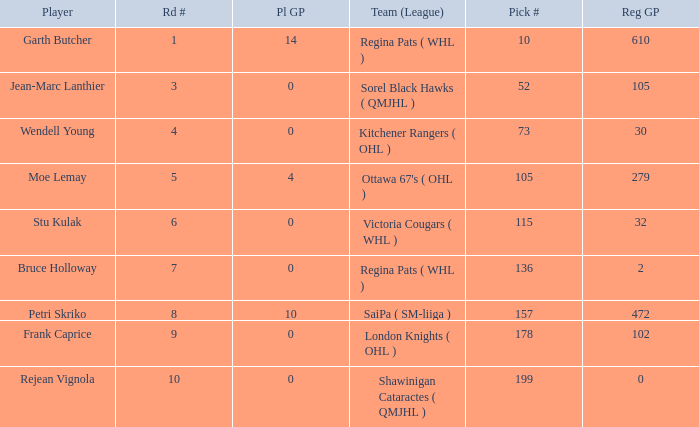Could you parse the entire table? {'header': ['Player', 'Rd #', 'Pl GP', 'Team (League)', 'Pick #', 'Reg GP'], 'rows': [['Garth Butcher', '1', '14', 'Regina Pats ( WHL )', '10', '610'], ['Jean-Marc Lanthier', '3', '0', 'Sorel Black Hawks ( QMJHL )', '52', '105'], ['Wendell Young', '4', '0', 'Kitchener Rangers ( OHL )', '73', '30'], ['Moe Lemay', '5', '4', "Ottawa 67's ( OHL )", '105', '279'], ['Stu Kulak', '6', '0', 'Victoria Cougars ( WHL )', '115', '32'], ['Bruce Holloway', '7', '0', 'Regina Pats ( WHL )', '136', '2'], ['Petri Skriko', '8', '10', 'SaiPa ( SM-liiga )', '157', '472'], ['Frank Caprice', '9', '0', 'London Knights ( OHL )', '178', '102'], ['Rejean Vignola', '10', '0', 'Shawinigan Cataractes ( QMJHL )', '199', '0']]} What is the total number of Pl GP when the pick number is 199 and the Reg GP is bigger than 0? None. 